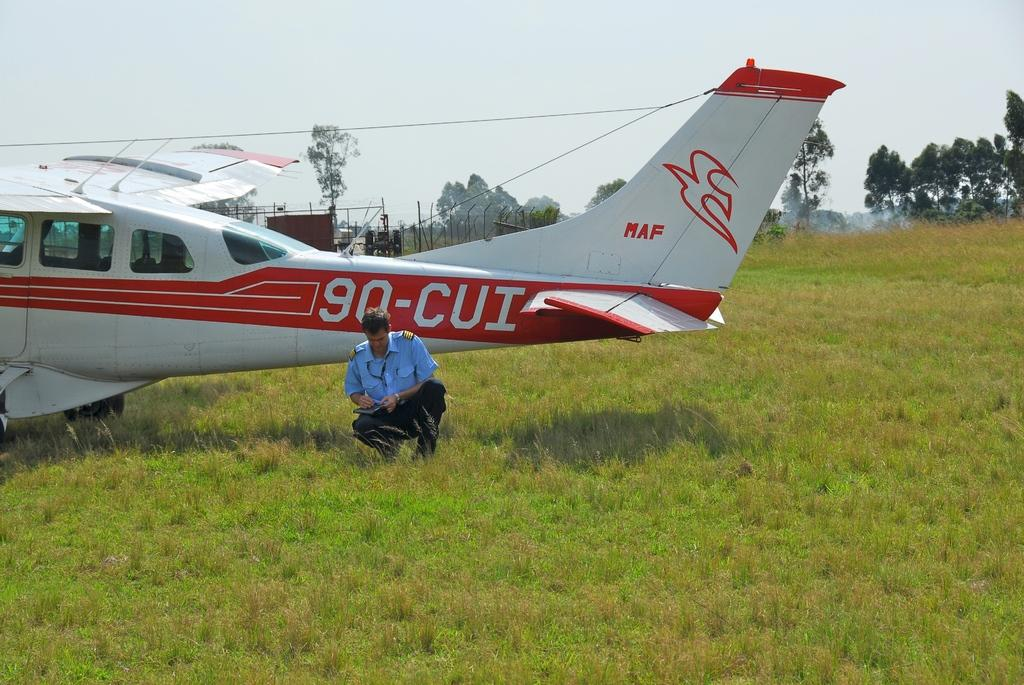<image>
Share a concise interpretation of the image provided. A man crouching in the grass in front of a small white and red plane with call sign 90-CUI. 